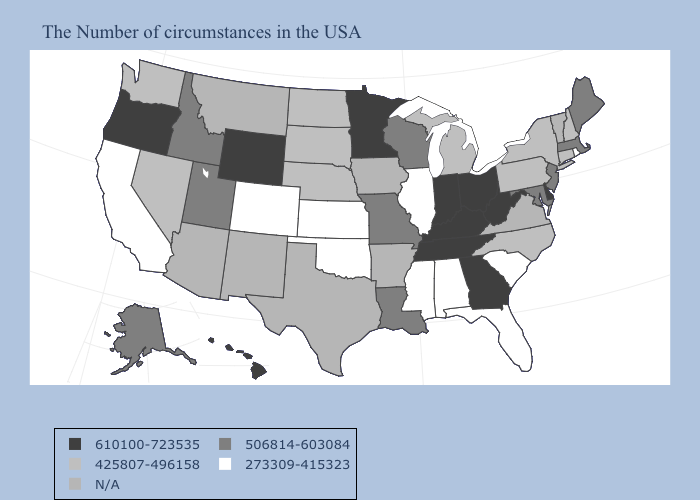Among the states that border Idaho , which have the lowest value?
Quick response, please. Nevada, Washington. What is the value of Colorado?
Short answer required. 273309-415323. Name the states that have a value in the range 610100-723535?
Answer briefly. Delaware, West Virginia, Ohio, Georgia, Kentucky, Indiana, Tennessee, Minnesota, Wyoming, Oregon, Hawaii. What is the value of Florida?
Quick response, please. 273309-415323. What is the highest value in states that border Wyoming?
Be succinct. 506814-603084. How many symbols are there in the legend?
Short answer required. 5. Among the states that border Tennessee , which have the highest value?
Write a very short answer. Georgia, Kentucky. Does North Dakota have the lowest value in the MidWest?
Quick response, please. No. Among the states that border New York , which have the lowest value?
Short answer required. Connecticut, Pennsylvania. Among the states that border Michigan , which have the lowest value?
Answer briefly. Wisconsin. Name the states that have a value in the range 506814-603084?
Be succinct. Maine, Massachusetts, New Jersey, Maryland, Wisconsin, Louisiana, Missouri, Utah, Idaho, Alaska. What is the lowest value in the MidWest?
Quick response, please. 273309-415323. Name the states that have a value in the range 610100-723535?
Keep it brief. Delaware, West Virginia, Ohio, Georgia, Kentucky, Indiana, Tennessee, Minnesota, Wyoming, Oregon, Hawaii. Name the states that have a value in the range 506814-603084?
Concise answer only. Maine, Massachusetts, New Jersey, Maryland, Wisconsin, Louisiana, Missouri, Utah, Idaho, Alaska. 